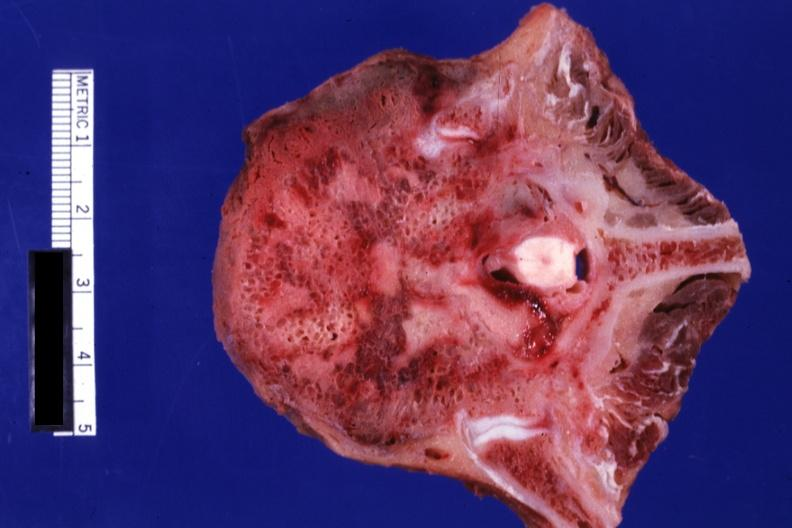s joints present?
Answer the question using a single word or phrase. Yes 